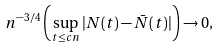<formula> <loc_0><loc_0><loc_500><loc_500>n ^ { - 3 / 4 } \left ( \sup _ { t \leq c n } | N ( t ) - \bar { N } ( t ) | \right ) \to 0 ,</formula> 